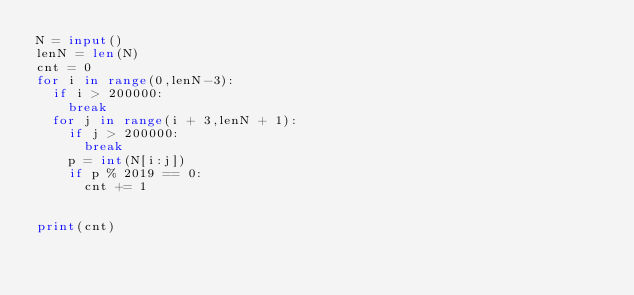Convert code to text. <code><loc_0><loc_0><loc_500><loc_500><_Python_>N = input()
lenN = len(N)
cnt = 0
for i in range(0,lenN-3):
  if i > 200000:
    break
  for j in range(i + 3,lenN + 1):
    if j > 200000:
      break
    p = int(N[i:j])
    if p % 2019 == 0:
      cnt += 1


print(cnt)</code> 